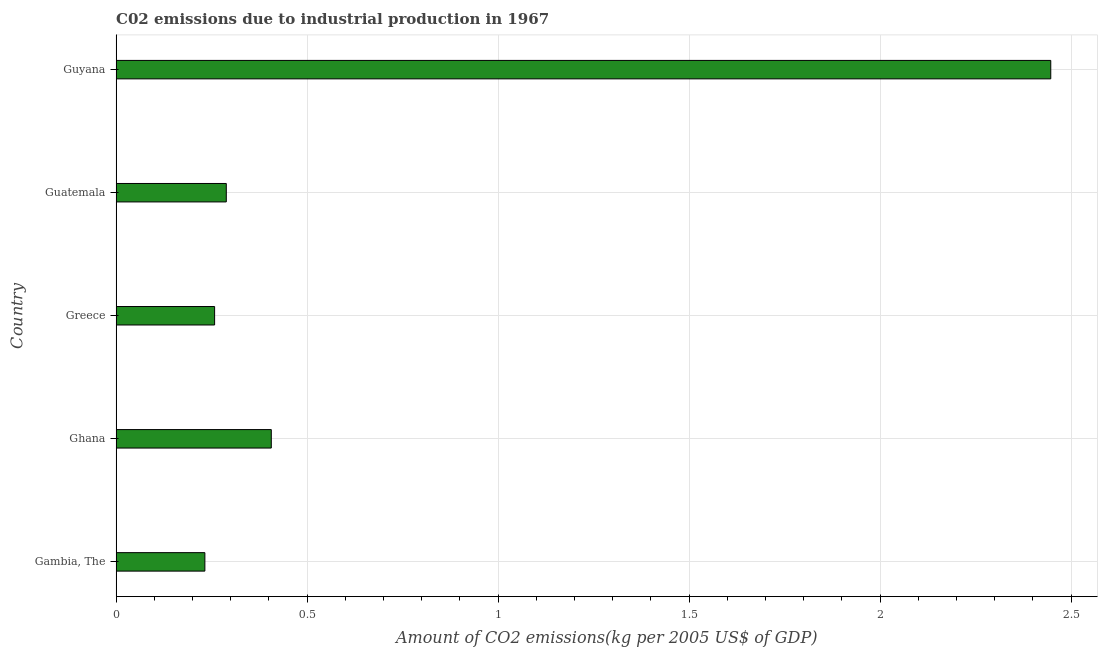Does the graph contain any zero values?
Your answer should be compact. No. What is the title of the graph?
Your response must be concise. C02 emissions due to industrial production in 1967. What is the label or title of the X-axis?
Make the answer very short. Amount of CO2 emissions(kg per 2005 US$ of GDP). What is the label or title of the Y-axis?
Your answer should be very brief. Country. What is the amount of co2 emissions in Ghana?
Give a very brief answer. 0.41. Across all countries, what is the maximum amount of co2 emissions?
Offer a terse response. 2.45. Across all countries, what is the minimum amount of co2 emissions?
Offer a terse response. 0.23. In which country was the amount of co2 emissions maximum?
Your response must be concise. Guyana. In which country was the amount of co2 emissions minimum?
Your answer should be compact. Gambia, The. What is the sum of the amount of co2 emissions?
Keep it short and to the point. 3.63. What is the difference between the amount of co2 emissions in Gambia, The and Ghana?
Provide a succinct answer. -0.17. What is the average amount of co2 emissions per country?
Give a very brief answer. 0.73. What is the median amount of co2 emissions?
Provide a short and direct response. 0.29. What is the ratio of the amount of co2 emissions in Ghana to that in Greece?
Offer a very short reply. 1.58. Is the amount of co2 emissions in Ghana less than that in Guatemala?
Provide a succinct answer. No. Is the difference between the amount of co2 emissions in Gambia, The and Ghana greater than the difference between any two countries?
Your response must be concise. No. What is the difference between the highest and the second highest amount of co2 emissions?
Make the answer very short. 2.04. Is the sum of the amount of co2 emissions in Greece and Guatemala greater than the maximum amount of co2 emissions across all countries?
Provide a succinct answer. No. What is the difference between the highest and the lowest amount of co2 emissions?
Offer a terse response. 2.21. How many bars are there?
Provide a succinct answer. 5. Are all the bars in the graph horizontal?
Your answer should be compact. Yes. What is the difference between two consecutive major ticks on the X-axis?
Keep it short and to the point. 0.5. Are the values on the major ticks of X-axis written in scientific E-notation?
Provide a short and direct response. No. What is the Amount of CO2 emissions(kg per 2005 US$ of GDP) of Gambia, The?
Your answer should be very brief. 0.23. What is the Amount of CO2 emissions(kg per 2005 US$ of GDP) of Ghana?
Offer a very short reply. 0.41. What is the Amount of CO2 emissions(kg per 2005 US$ of GDP) in Greece?
Your answer should be compact. 0.26. What is the Amount of CO2 emissions(kg per 2005 US$ of GDP) in Guatemala?
Your answer should be very brief. 0.29. What is the Amount of CO2 emissions(kg per 2005 US$ of GDP) in Guyana?
Your response must be concise. 2.45. What is the difference between the Amount of CO2 emissions(kg per 2005 US$ of GDP) in Gambia, The and Ghana?
Your answer should be very brief. -0.17. What is the difference between the Amount of CO2 emissions(kg per 2005 US$ of GDP) in Gambia, The and Greece?
Your response must be concise. -0.03. What is the difference between the Amount of CO2 emissions(kg per 2005 US$ of GDP) in Gambia, The and Guatemala?
Your response must be concise. -0.06. What is the difference between the Amount of CO2 emissions(kg per 2005 US$ of GDP) in Gambia, The and Guyana?
Offer a very short reply. -2.21. What is the difference between the Amount of CO2 emissions(kg per 2005 US$ of GDP) in Ghana and Greece?
Provide a succinct answer. 0.15. What is the difference between the Amount of CO2 emissions(kg per 2005 US$ of GDP) in Ghana and Guatemala?
Ensure brevity in your answer.  0.12. What is the difference between the Amount of CO2 emissions(kg per 2005 US$ of GDP) in Ghana and Guyana?
Provide a short and direct response. -2.04. What is the difference between the Amount of CO2 emissions(kg per 2005 US$ of GDP) in Greece and Guatemala?
Your answer should be compact. -0.03. What is the difference between the Amount of CO2 emissions(kg per 2005 US$ of GDP) in Greece and Guyana?
Provide a succinct answer. -2.19. What is the difference between the Amount of CO2 emissions(kg per 2005 US$ of GDP) in Guatemala and Guyana?
Your response must be concise. -2.16. What is the ratio of the Amount of CO2 emissions(kg per 2005 US$ of GDP) in Gambia, The to that in Ghana?
Your answer should be very brief. 0.57. What is the ratio of the Amount of CO2 emissions(kg per 2005 US$ of GDP) in Gambia, The to that in Greece?
Give a very brief answer. 0.9. What is the ratio of the Amount of CO2 emissions(kg per 2005 US$ of GDP) in Gambia, The to that in Guatemala?
Your answer should be very brief. 0.81. What is the ratio of the Amount of CO2 emissions(kg per 2005 US$ of GDP) in Gambia, The to that in Guyana?
Keep it short and to the point. 0.1. What is the ratio of the Amount of CO2 emissions(kg per 2005 US$ of GDP) in Ghana to that in Greece?
Make the answer very short. 1.58. What is the ratio of the Amount of CO2 emissions(kg per 2005 US$ of GDP) in Ghana to that in Guatemala?
Provide a succinct answer. 1.41. What is the ratio of the Amount of CO2 emissions(kg per 2005 US$ of GDP) in Ghana to that in Guyana?
Ensure brevity in your answer.  0.17. What is the ratio of the Amount of CO2 emissions(kg per 2005 US$ of GDP) in Greece to that in Guatemala?
Offer a very short reply. 0.89. What is the ratio of the Amount of CO2 emissions(kg per 2005 US$ of GDP) in Greece to that in Guyana?
Offer a terse response. 0.1. What is the ratio of the Amount of CO2 emissions(kg per 2005 US$ of GDP) in Guatemala to that in Guyana?
Offer a terse response. 0.12. 